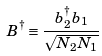<formula> <loc_0><loc_0><loc_500><loc_500>B ^ { \dagger } \equiv \frac { b _ { 2 } ^ { \dagger } b _ { 1 } } { \sqrt { N _ { 2 } N _ { 1 } } }</formula> 